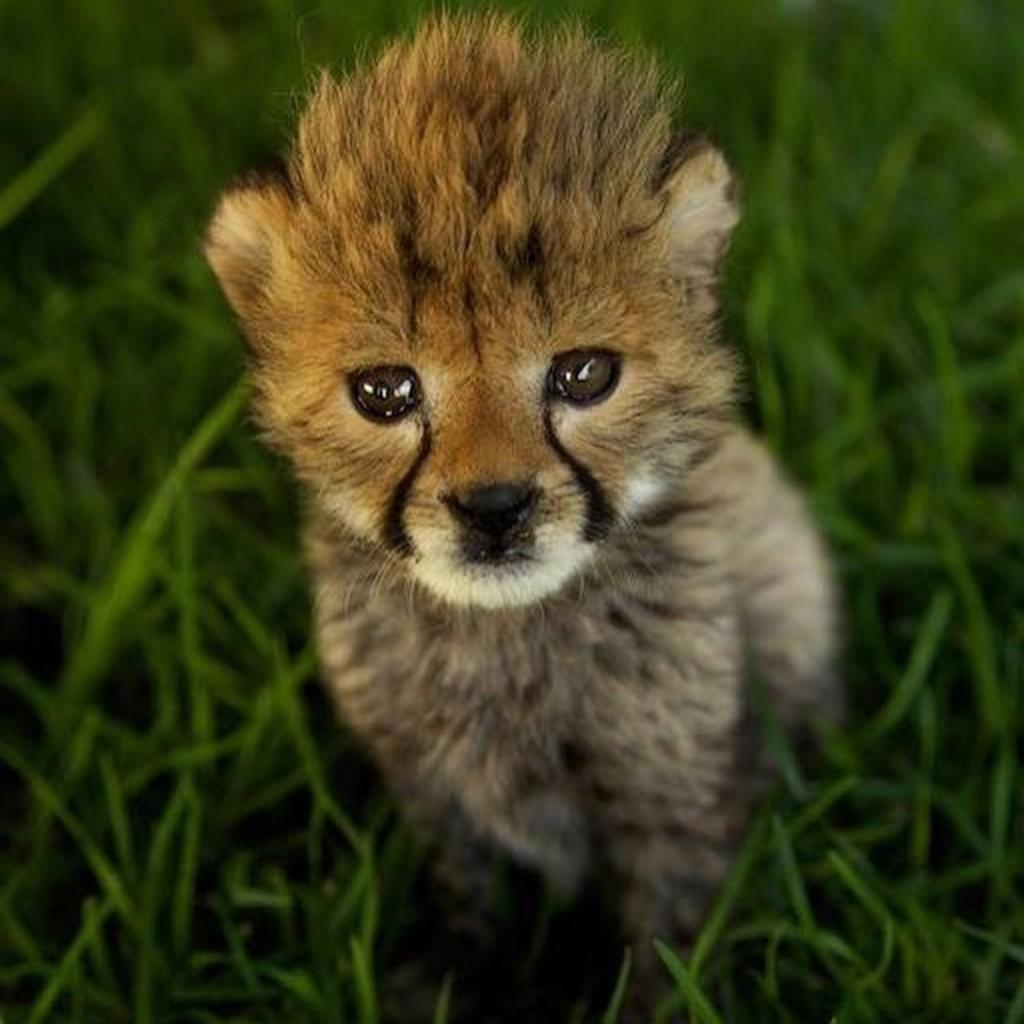What type of creature can be seen in the image? There is an animal in the image. Where is the animal located in the image? The animal is in the middle of the grass. What color of paint is the animal using to express its feelings of shame in the image? There is no paint or indication of shame present in the image; it simply features an animal in the grass. 